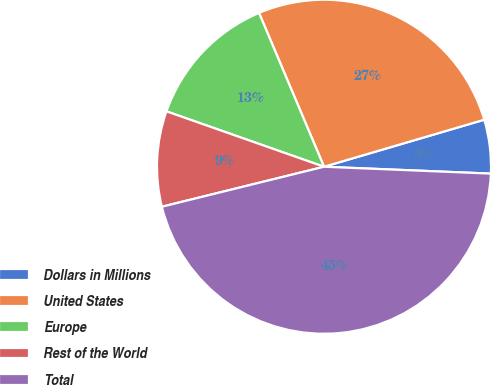Convert chart to OTSL. <chart><loc_0><loc_0><loc_500><loc_500><pie_chart><fcel>Dollars in Millions<fcel>United States<fcel>Europe<fcel>Rest of the World<fcel>Total<nl><fcel>5.2%<fcel>26.82%<fcel>13.26%<fcel>9.23%<fcel>45.5%<nl></chart> 